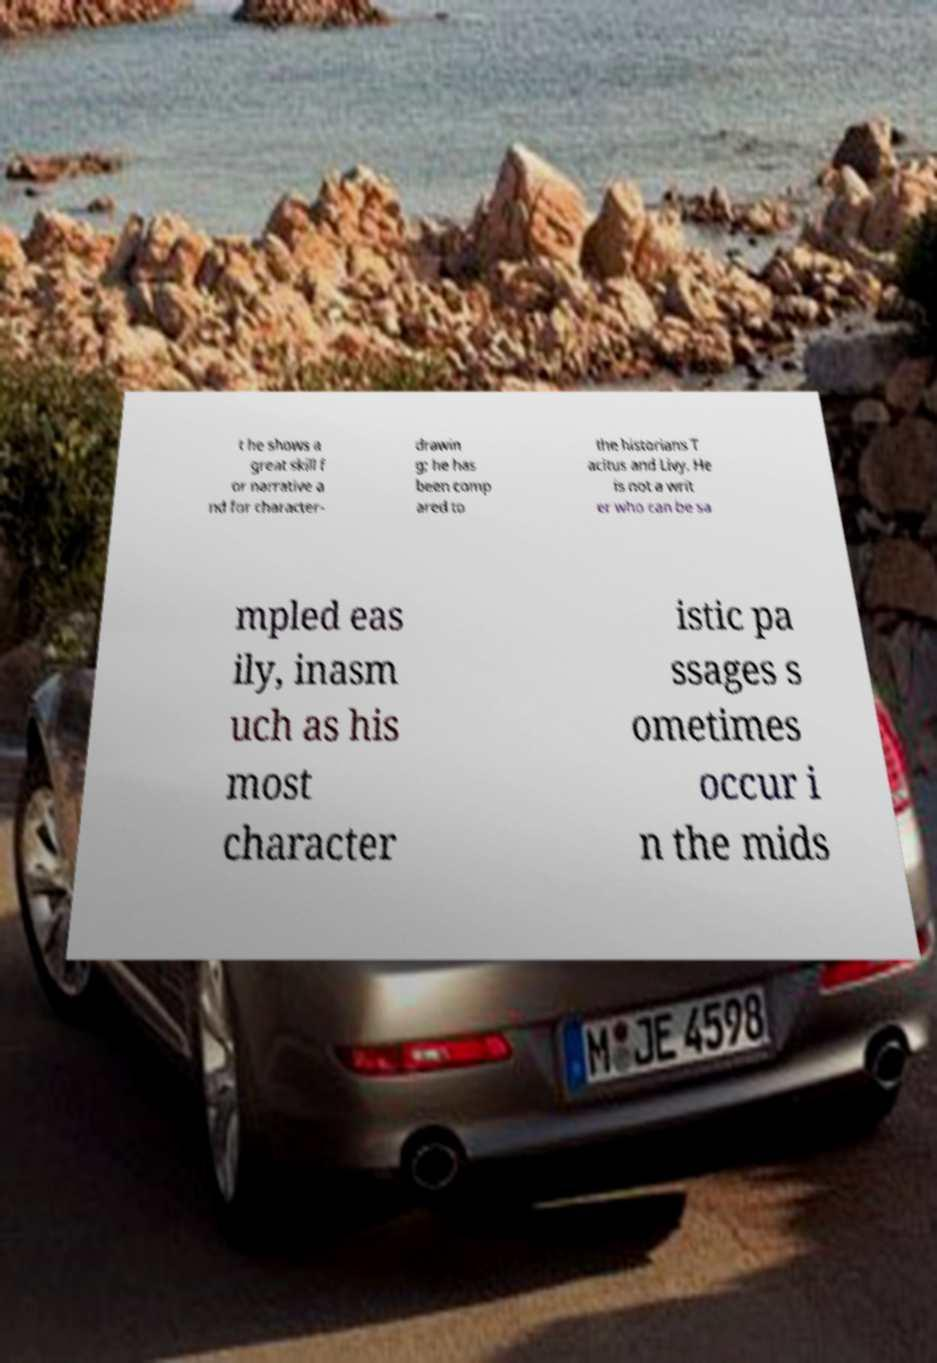Can you accurately transcribe the text from the provided image for me? t he shows a great skill f or narrative a nd for character- drawin g; he has been comp ared to the historians T acitus and Livy. He is not a writ er who can be sa mpled eas ily, inasm uch as his most character istic pa ssages s ometimes occur i n the mids 